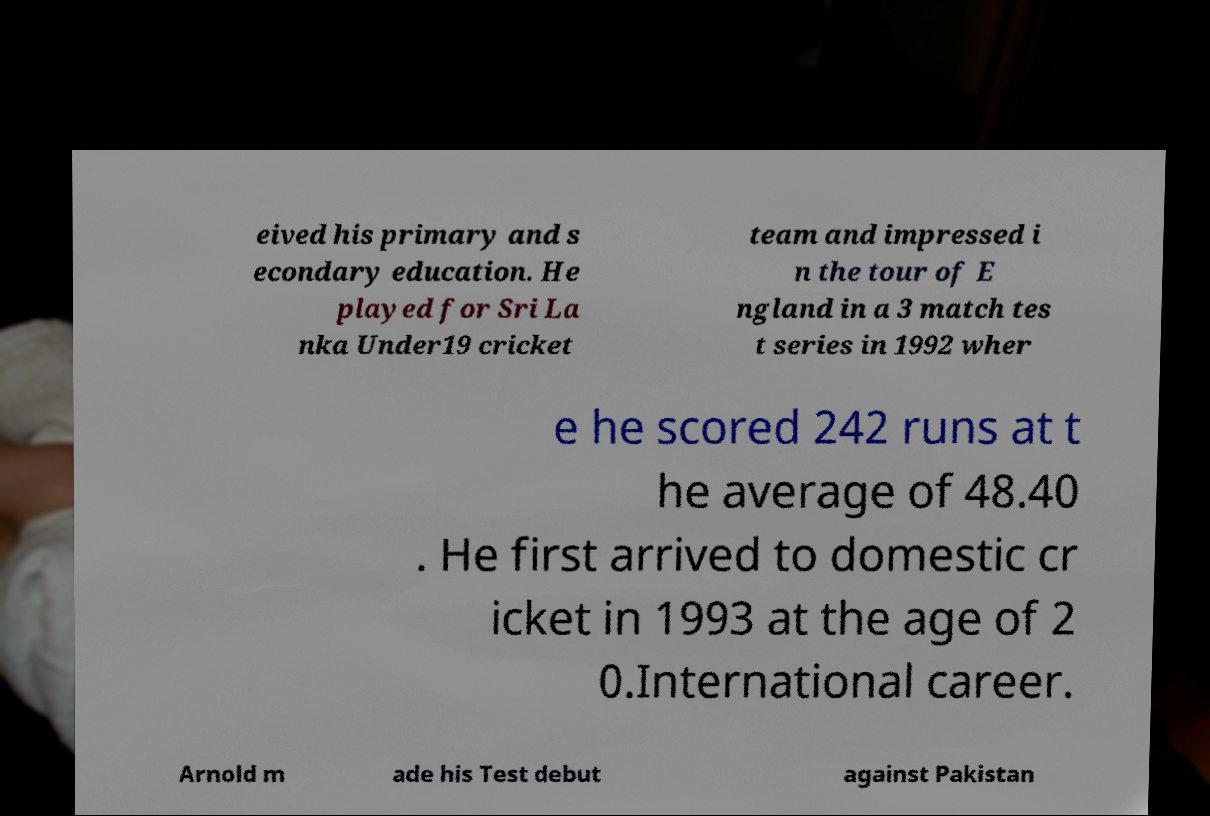I need the written content from this picture converted into text. Can you do that? eived his primary and s econdary education. He played for Sri La nka Under19 cricket team and impressed i n the tour of E ngland in a 3 match tes t series in 1992 wher e he scored 242 runs at t he average of 48.40 . He first arrived to domestic cr icket in 1993 at the age of 2 0.International career. Arnold m ade his Test debut against Pakistan 